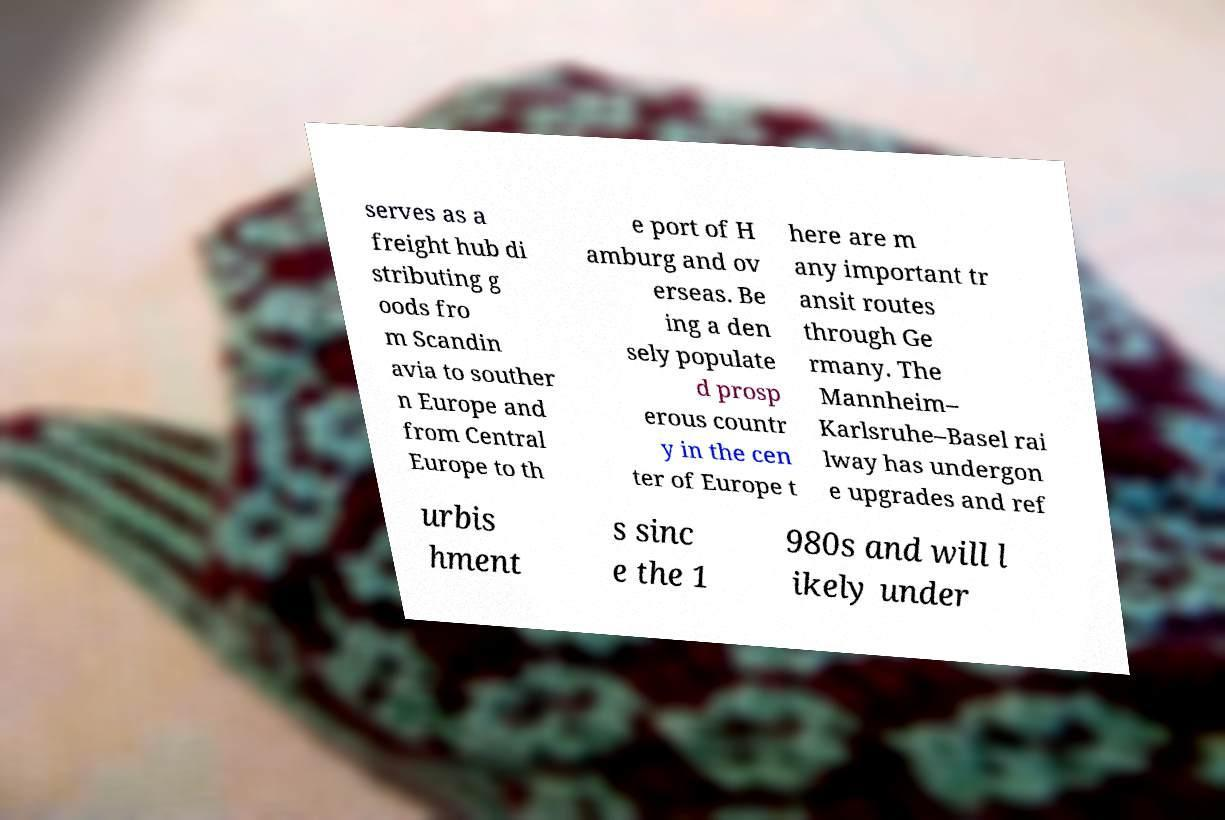There's text embedded in this image that I need extracted. Can you transcribe it verbatim? serves as a freight hub di stributing g oods fro m Scandin avia to souther n Europe and from Central Europe to th e port of H amburg and ov erseas. Be ing a den sely populate d prosp erous countr y in the cen ter of Europe t here are m any important tr ansit routes through Ge rmany. The Mannheim– Karlsruhe–Basel rai lway has undergon e upgrades and ref urbis hment s sinc e the 1 980s and will l ikely under 